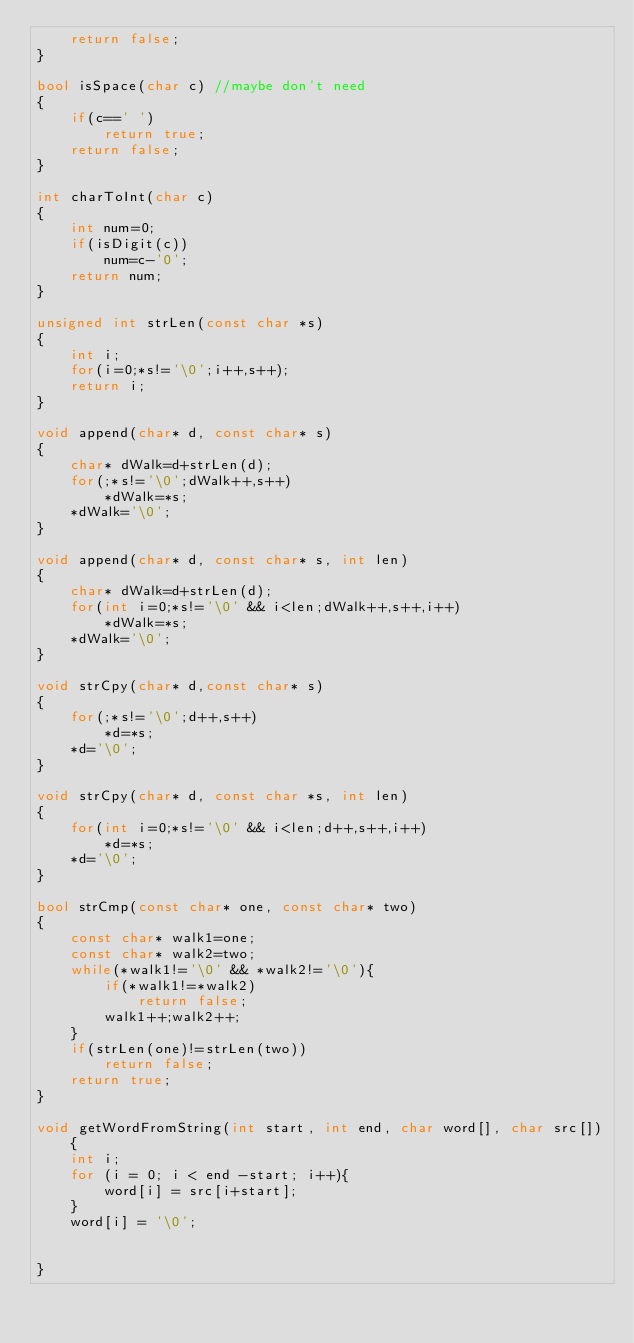<code> <loc_0><loc_0><loc_500><loc_500><_C++_>    return false;
}

bool isSpace(char c) //maybe don't need
{
    if(c==' ')
        return true;
    return false;
}

int charToInt(char c)
{
    int num=0;
    if(isDigit(c))
        num=c-'0';
    return num;
}

unsigned int strLen(const char *s)
{
    int i;
    for(i=0;*s!='\0';i++,s++);
    return i;
}

void append(char* d, const char* s)
{
    char* dWalk=d+strLen(d);
    for(;*s!='\0';dWalk++,s++)
        *dWalk=*s;
    *dWalk='\0';
}

void append(char* d, const char* s, int len)
{
    char* dWalk=d+strLen(d);
    for(int i=0;*s!='\0' && i<len;dWalk++,s++,i++)
        *dWalk=*s;
    *dWalk='\0';
}

void strCpy(char* d,const char* s)
{
    for(;*s!='\0';d++,s++)
        *d=*s;
    *d='\0';
}

void strCpy(char* d, const char *s, int len)
{
    for(int i=0;*s!='\0' && i<len;d++,s++,i++)
        *d=*s;
    *d='\0';
}

bool strCmp(const char* one, const char* two)
{
    const char* walk1=one;
    const char* walk2=two;
    while(*walk1!='\0' && *walk2!='\0'){
        if(*walk1!=*walk2)
            return false;
        walk1++;walk2++;
    }
    if(strLen(one)!=strLen(two))
        return false;
    return true;
}

void getWordFromString(int start, int end, char word[], char src[]){
    int i;
    for (i = 0; i < end -start; i++){
        word[i] = src[i+start];
    }
    word[i] = '\0';


}



</code> 